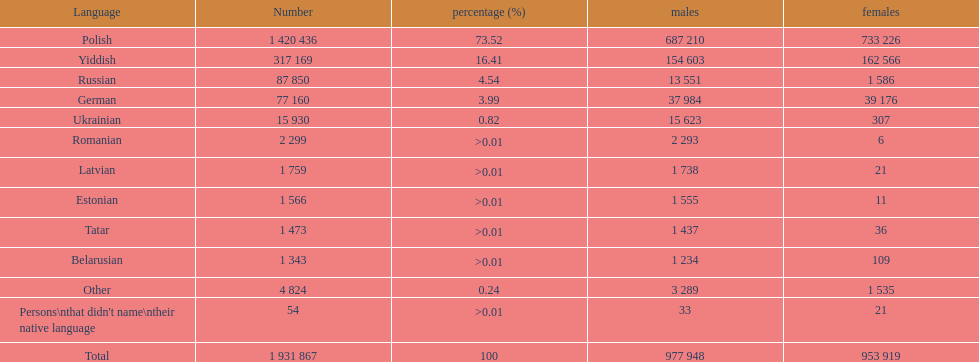What was the second most frequently spoken language in poland after russian? German. 